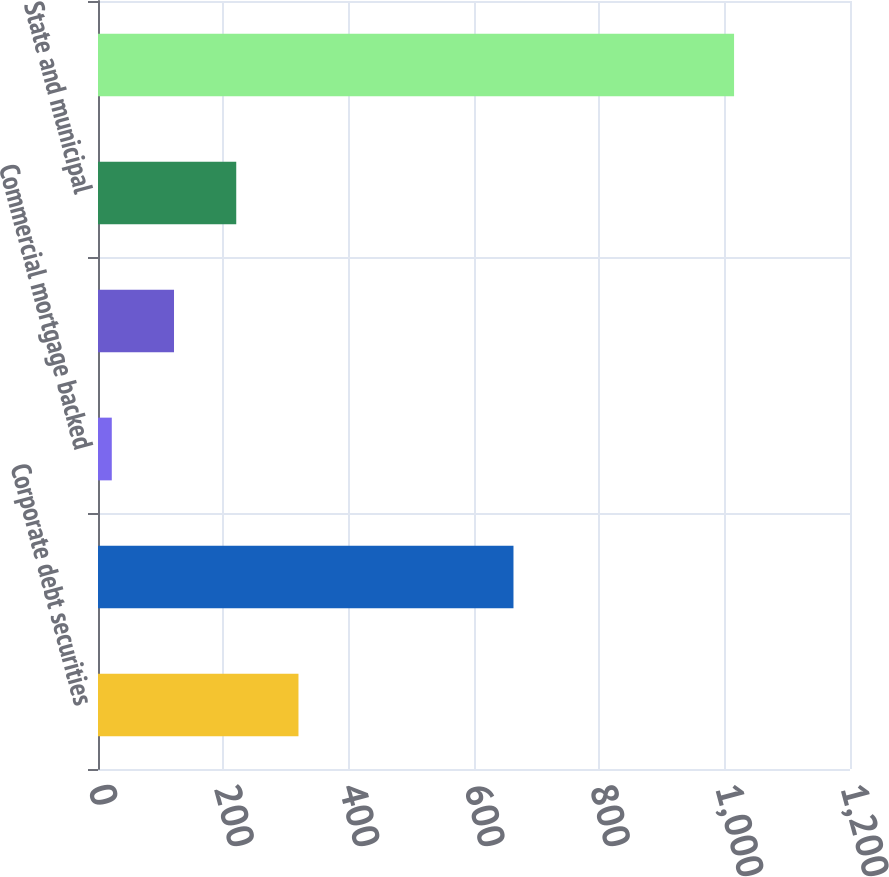<chart> <loc_0><loc_0><loc_500><loc_500><bar_chart><fcel>Corporate debt securities<fcel>Residential mortgage backed<fcel>Commercial mortgage backed<fcel>Asset backed securities<fcel>State and municipal<fcel>Total<nl><fcel>319.9<fcel>663<fcel>22<fcel>121.3<fcel>220.6<fcel>1015<nl></chart> 